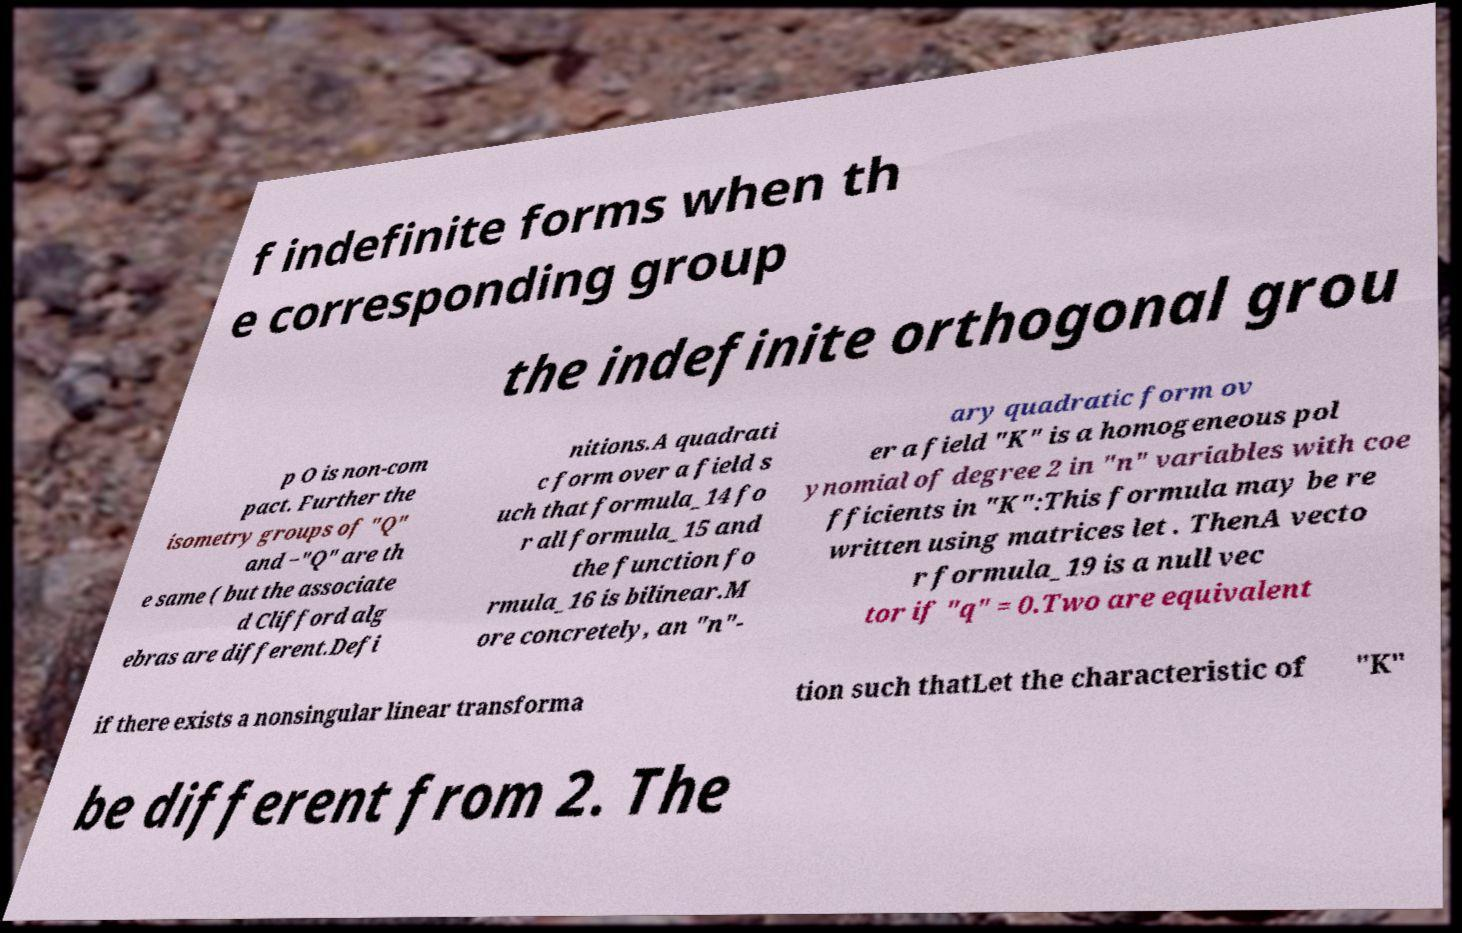Can you accurately transcribe the text from the provided image for me? f indefinite forms when th e corresponding group the indefinite orthogonal grou p O is non-com pact. Further the isometry groups of "Q" and −"Q" are th e same ( but the associate d Clifford alg ebras are different.Defi nitions.A quadrati c form over a field s uch that formula_14 fo r all formula_15 and the function fo rmula_16 is bilinear.M ore concretely, an "n"- ary quadratic form ov er a field "K" is a homogeneous pol ynomial of degree 2 in "n" variables with coe fficients in "K":This formula may be re written using matrices let . ThenA vecto r formula_19 is a null vec tor if "q" = 0.Two are equivalent if there exists a nonsingular linear transforma tion such thatLet the characteristic of "K" be different from 2. The 